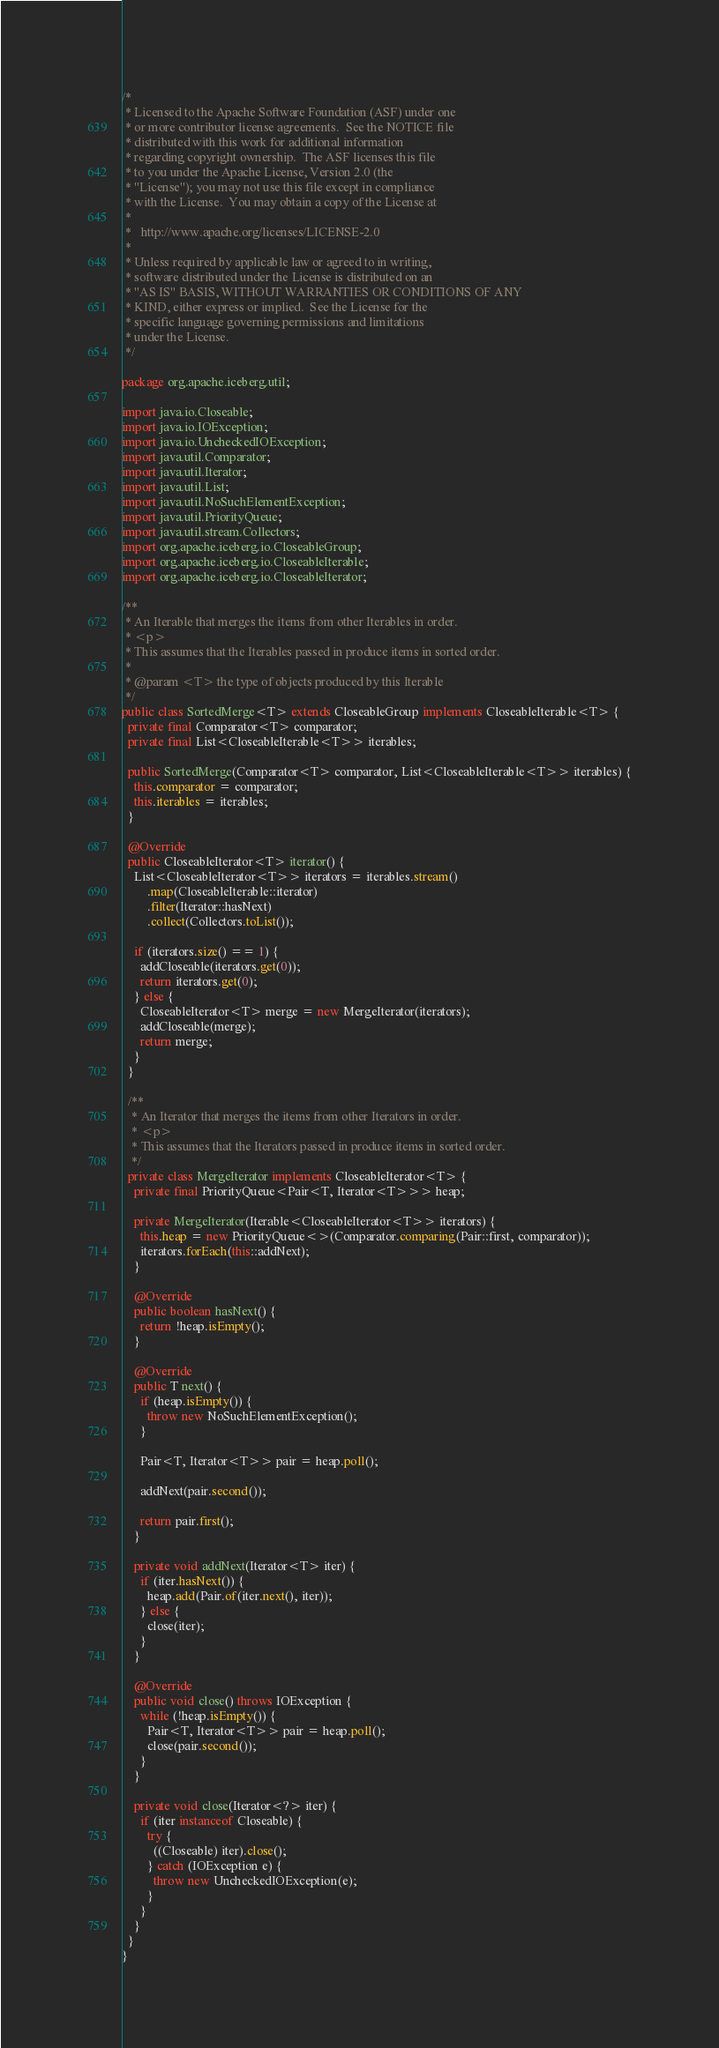<code> <loc_0><loc_0><loc_500><loc_500><_Java_>/*
 * Licensed to the Apache Software Foundation (ASF) under one
 * or more contributor license agreements.  See the NOTICE file
 * distributed with this work for additional information
 * regarding copyright ownership.  The ASF licenses this file
 * to you under the Apache License, Version 2.0 (the
 * "License"); you may not use this file except in compliance
 * with the License.  You may obtain a copy of the License at
 *
 *   http://www.apache.org/licenses/LICENSE-2.0
 *
 * Unless required by applicable law or agreed to in writing,
 * software distributed under the License is distributed on an
 * "AS IS" BASIS, WITHOUT WARRANTIES OR CONDITIONS OF ANY
 * KIND, either express or implied.  See the License for the
 * specific language governing permissions and limitations
 * under the License.
 */

package org.apache.iceberg.util;

import java.io.Closeable;
import java.io.IOException;
import java.io.UncheckedIOException;
import java.util.Comparator;
import java.util.Iterator;
import java.util.List;
import java.util.NoSuchElementException;
import java.util.PriorityQueue;
import java.util.stream.Collectors;
import org.apache.iceberg.io.CloseableGroup;
import org.apache.iceberg.io.CloseableIterable;
import org.apache.iceberg.io.CloseableIterator;

/**
 * An Iterable that merges the items from other Iterables in order.
 * <p>
 * This assumes that the Iterables passed in produce items in sorted order.
 *
 * @param <T> the type of objects produced by this Iterable
 */
public class SortedMerge<T> extends CloseableGroup implements CloseableIterable<T> {
  private final Comparator<T> comparator;
  private final List<CloseableIterable<T>> iterables;

  public SortedMerge(Comparator<T> comparator, List<CloseableIterable<T>> iterables) {
    this.comparator = comparator;
    this.iterables = iterables;
  }

  @Override
  public CloseableIterator<T> iterator() {
    List<CloseableIterator<T>> iterators = iterables.stream()
        .map(CloseableIterable::iterator)
        .filter(Iterator::hasNext)
        .collect(Collectors.toList());

    if (iterators.size() == 1) {
      addCloseable(iterators.get(0));
      return iterators.get(0);
    } else {
      CloseableIterator<T> merge = new MergeIterator(iterators);
      addCloseable(merge);
      return merge;
    }
  }

  /**
   * An Iterator that merges the items from other Iterators in order.
   * <p>
   * This assumes that the Iterators passed in produce items in sorted order.
   */
  private class MergeIterator implements CloseableIterator<T> {
    private final PriorityQueue<Pair<T, Iterator<T>>> heap;

    private MergeIterator(Iterable<CloseableIterator<T>> iterators) {
      this.heap = new PriorityQueue<>(Comparator.comparing(Pair::first, comparator));
      iterators.forEach(this::addNext);
    }

    @Override
    public boolean hasNext() {
      return !heap.isEmpty();
    }

    @Override
    public T next() {
      if (heap.isEmpty()) {
        throw new NoSuchElementException();
      }

      Pair<T, Iterator<T>> pair = heap.poll();

      addNext(pair.second());

      return pair.first();
    }

    private void addNext(Iterator<T> iter) {
      if (iter.hasNext()) {
        heap.add(Pair.of(iter.next(), iter));
      } else {
        close(iter);
      }
    }

    @Override
    public void close() throws IOException {
      while (!heap.isEmpty()) {
        Pair<T, Iterator<T>> pair = heap.poll();
        close(pair.second());
      }
    }

    private void close(Iterator<?> iter) {
      if (iter instanceof Closeable) {
        try {
          ((Closeable) iter).close();
        } catch (IOException e) {
          throw new UncheckedIOException(e);
        }
      }
    }
  }
}
</code> 